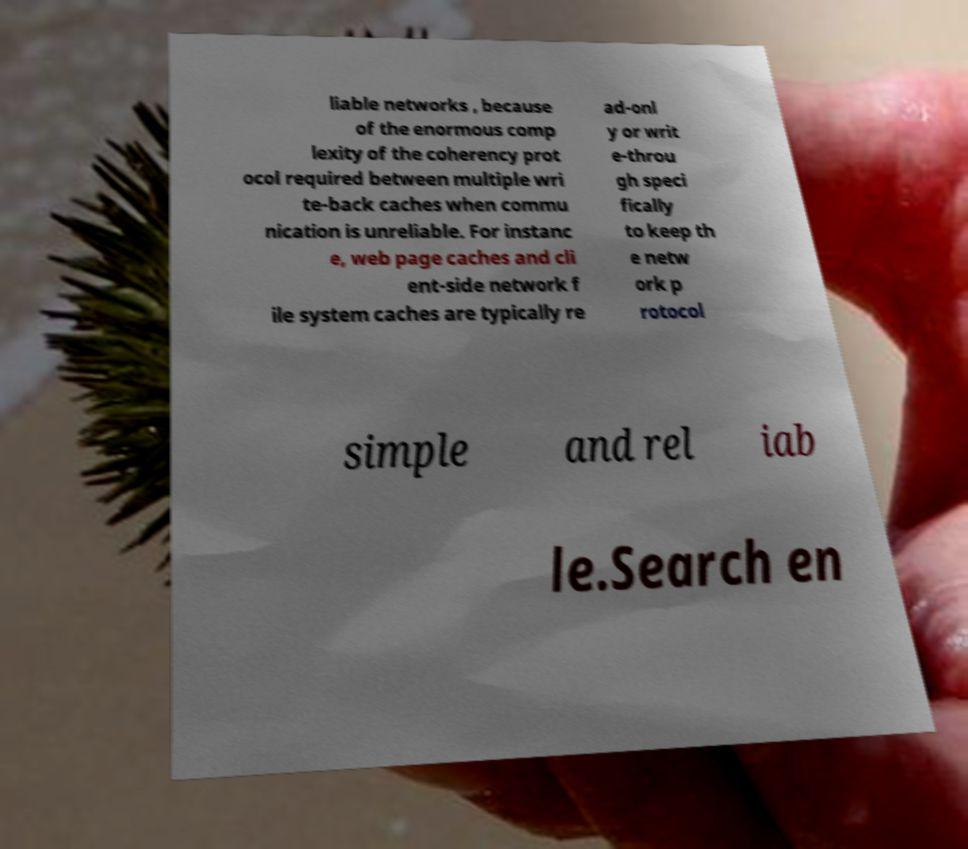I need the written content from this picture converted into text. Can you do that? liable networks , because of the enormous comp lexity of the coherency prot ocol required between multiple wri te-back caches when commu nication is unreliable. For instanc e, web page caches and cli ent-side network f ile system caches are typically re ad-onl y or writ e-throu gh speci fically to keep th e netw ork p rotocol simple and rel iab le.Search en 